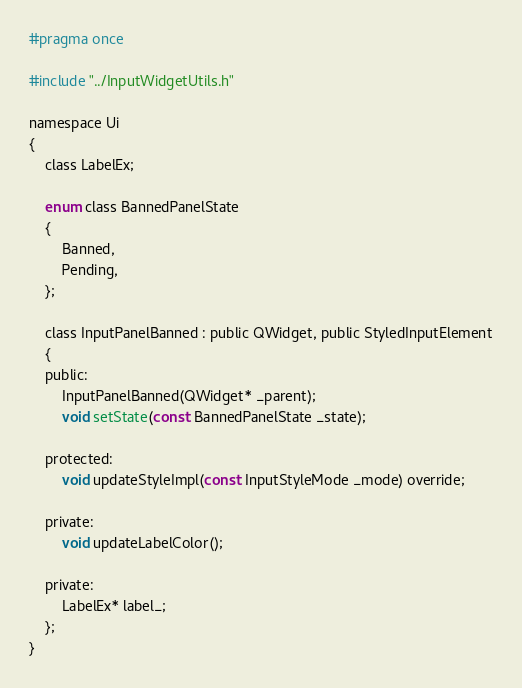<code> <loc_0><loc_0><loc_500><loc_500><_C_>#pragma once

#include "../InputWidgetUtils.h"

namespace Ui
{
    class LabelEx;

    enum class BannedPanelState
    {
        Banned,
        Pending,
    };

    class InputPanelBanned : public QWidget, public StyledInputElement
    {
    public:
        InputPanelBanned(QWidget* _parent);
        void setState(const BannedPanelState _state);

    protected:
        void updateStyleImpl(const InputStyleMode _mode) override;

    private:
        void updateLabelColor();

    private:
        LabelEx* label_;
    };
}</code> 